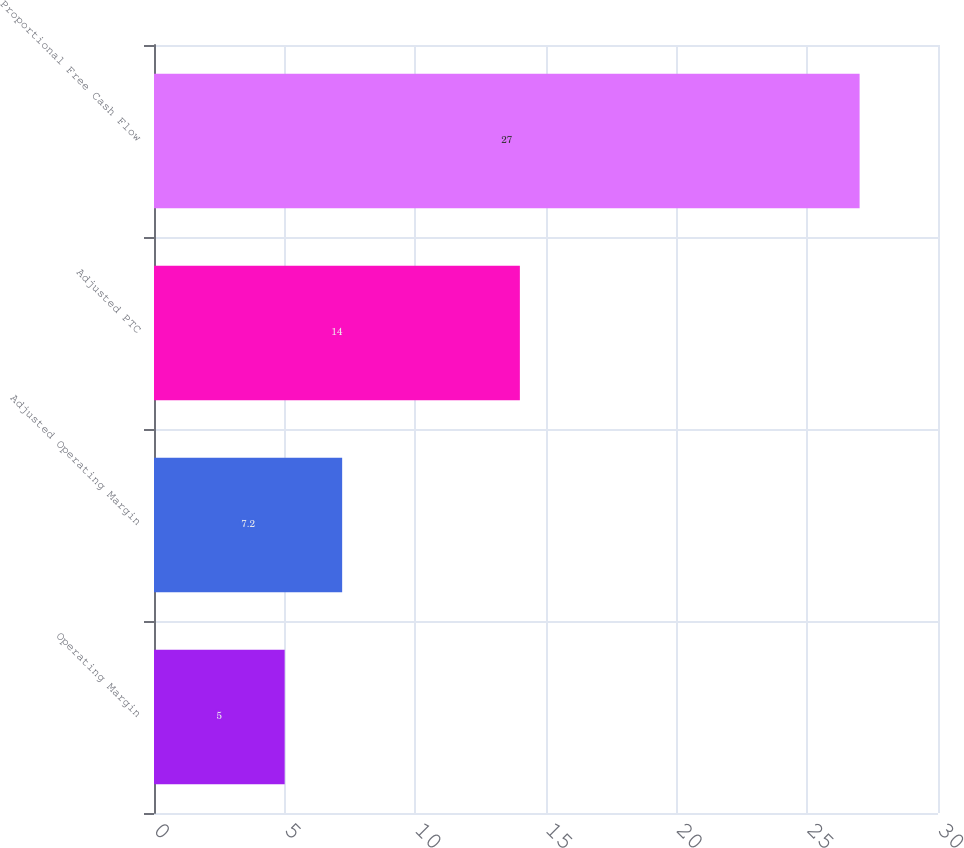Convert chart to OTSL. <chart><loc_0><loc_0><loc_500><loc_500><bar_chart><fcel>Operating Margin<fcel>Adjusted Operating Margin<fcel>Adjusted PTC<fcel>Proportional Free Cash Flow<nl><fcel>5<fcel>7.2<fcel>14<fcel>27<nl></chart> 